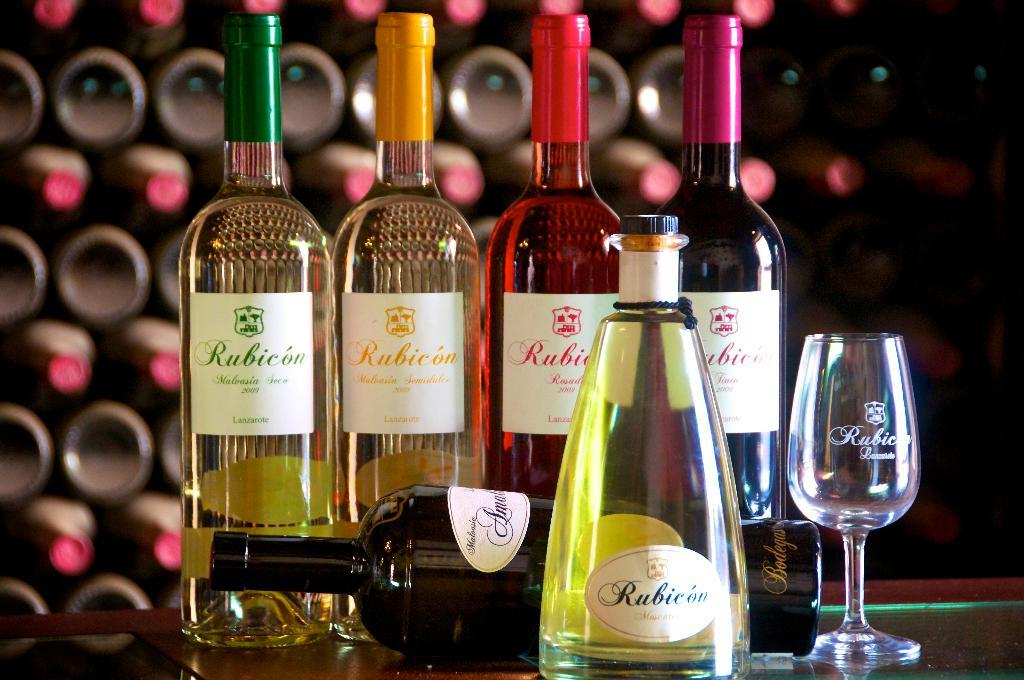<image>
Write a terse but informative summary of the picture. Bottles with one that says "Rubicon" on it. 